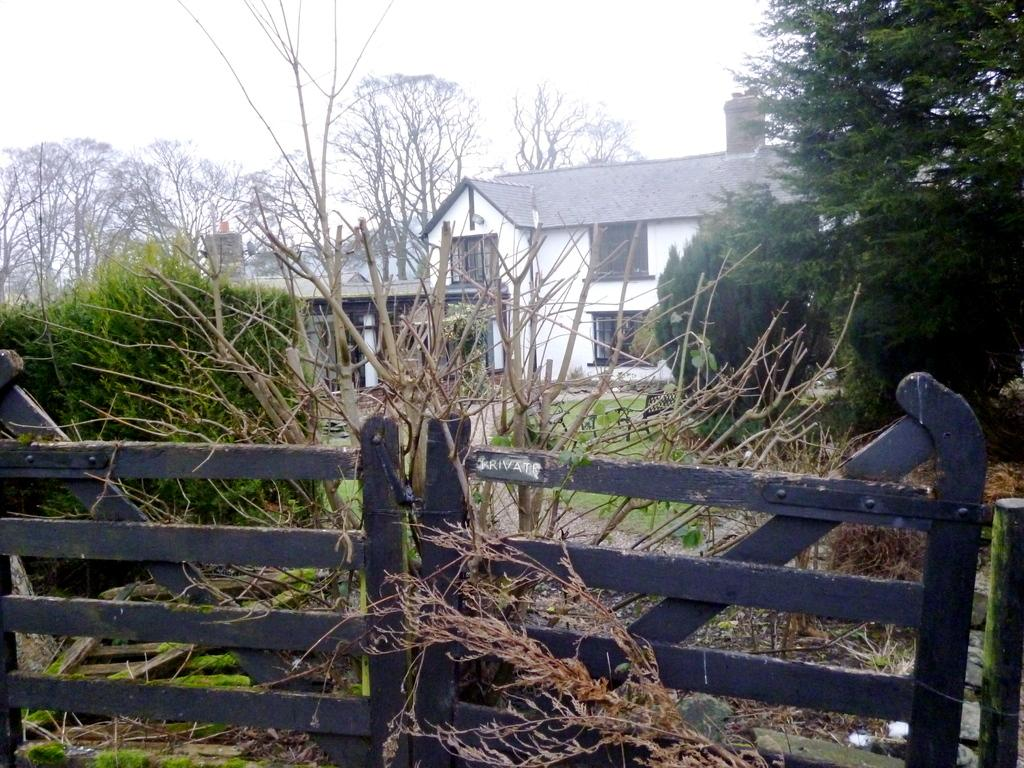What type of living organisms can be seen in the image? Plants and trees are visible in the image. What type of structure is present in the image? There is a wooden fence in the image. What type of building is in the image? There is a house in the image. What can be seen in the background of the image? The sky is visible in the background of the image. What type of support does the scarecrow provide in the image? There is no scarecrow present in the image. What reward can be seen hanging from the trees in the image? There are no rewards hanging from the trees in the image. 